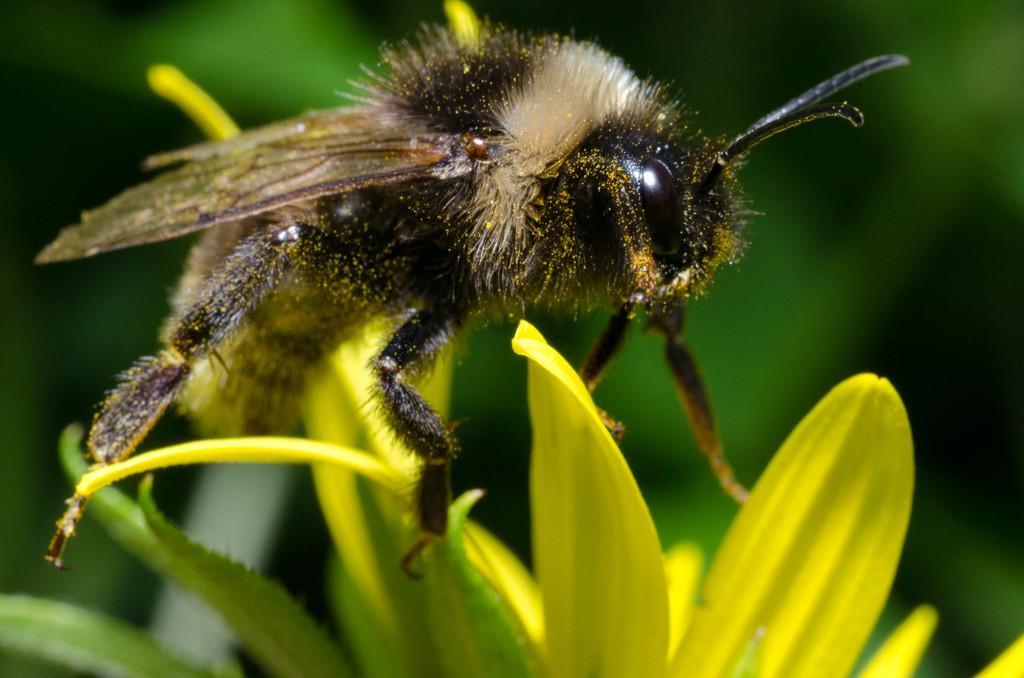Could you give a brief overview of what you see in this image? In this image there is an insect on the flower petals and the background of the image is blur. 